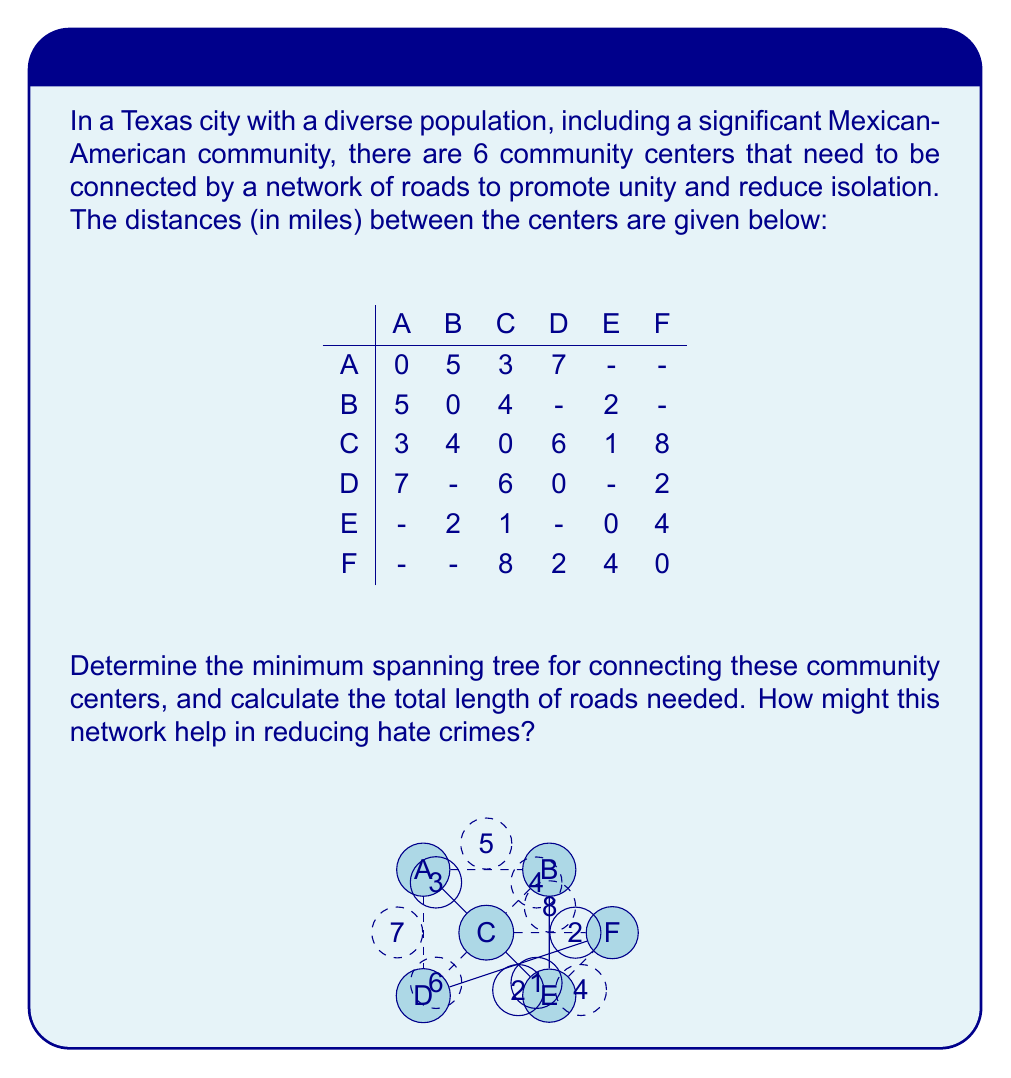Can you answer this question? To find the minimum spanning tree, we'll use Kruskal's algorithm:

1. Sort all edges by weight (distance) in ascending order:
   C-E (1), B-E (2), D-F (2), A-C (3), B-C (4), E-F (4), A-B (5), C-D (6), A-D (7), C-F (8)

2. Start with an empty graph and add edges in order, skipping those that would create a cycle:

   - Add C-E (1)
   - Add B-E (2)
   - Add D-F (2)
   - Add A-C (3)
   - Skip B-C (4) as it would create a cycle
   - Skip E-F (4) as it would create a cycle
   - Skip A-B (5) as it would create a cycle
   - Skip C-D (6) as it would create a cycle
   - Skip A-D (7) as it would create a cycle
   - Skip C-F (8) as it would create a cycle

3. The minimum spanning tree is now complete with 5 edges (the minimum needed to connect 6 vertices).

The total length of roads needed is the sum of the distances of the selected edges:
$$ 1 + 2 + 2 + 3 = 8 \text{ miles} $$

This network can help reduce hate crimes by:
1. Improving accessibility between diverse communities
2. Facilitating cultural exchange and understanding
3. Enabling quicker response times for law enforcement
4. Creating shared spaces for community engagement and education
Answer: The minimum spanning tree consists of edges C-E, B-E, D-F, and A-C, with a total length of 8 miles. 